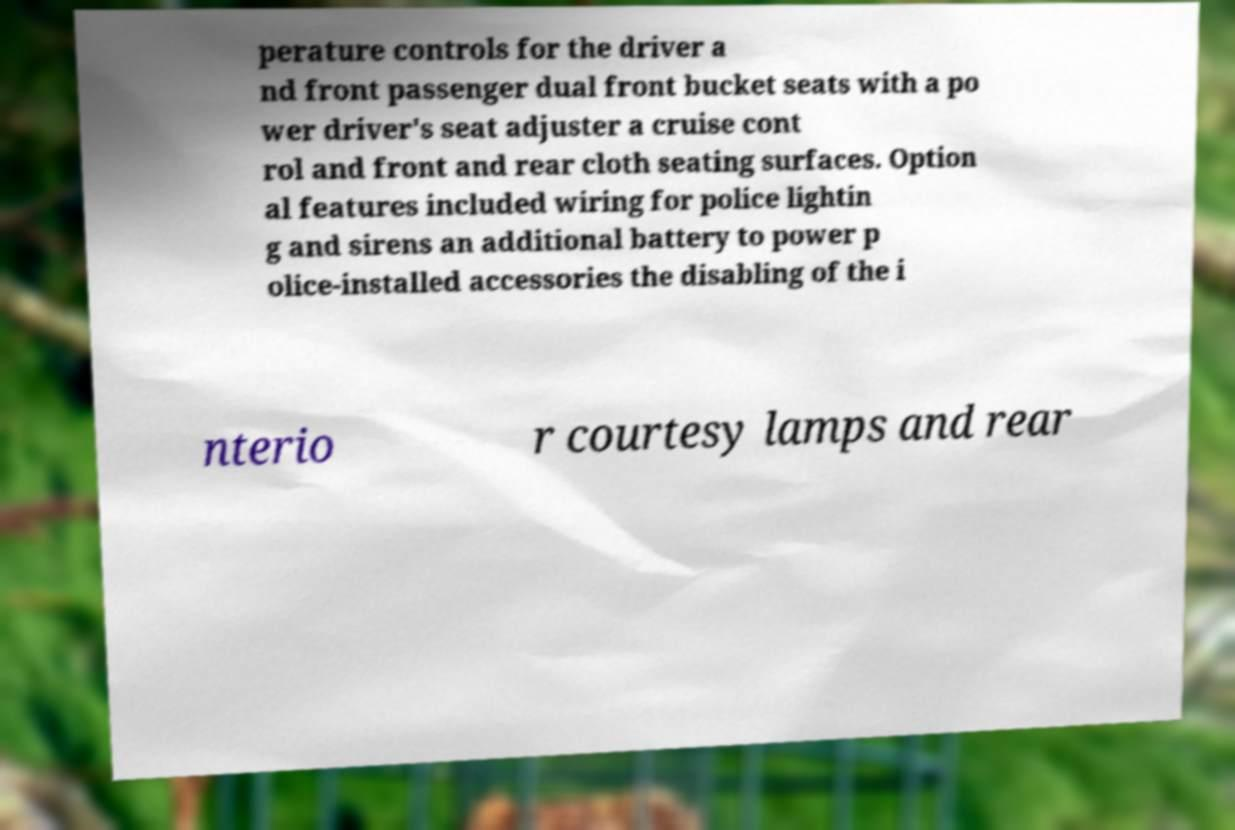I need the written content from this picture converted into text. Can you do that? perature controls for the driver a nd front passenger dual front bucket seats with a po wer driver's seat adjuster a cruise cont rol and front and rear cloth seating surfaces. Option al features included wiring for police lightin g and sirens an additional battery to power p olice-installed accessories the disabling of the i nterio r courtesy lamps and rear 